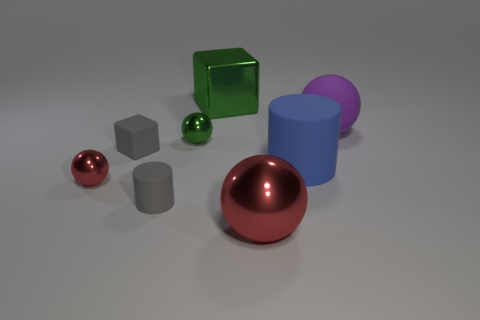Add 1 big yellow cylinders. How many objects exist? 9 Subtract all cubes. How many objects are left? 6 Subtract 2 red balls. How many objects are left? 6 Subtract all big red shiny balls. Subtract all tiny red metallic objects. How many objects are left? 6 Add 8 large blue matte cylinders. How many large blue matte cylinders are left? 9 Add 2 tiny red spheres. How many tiny red spheres exist? 3 